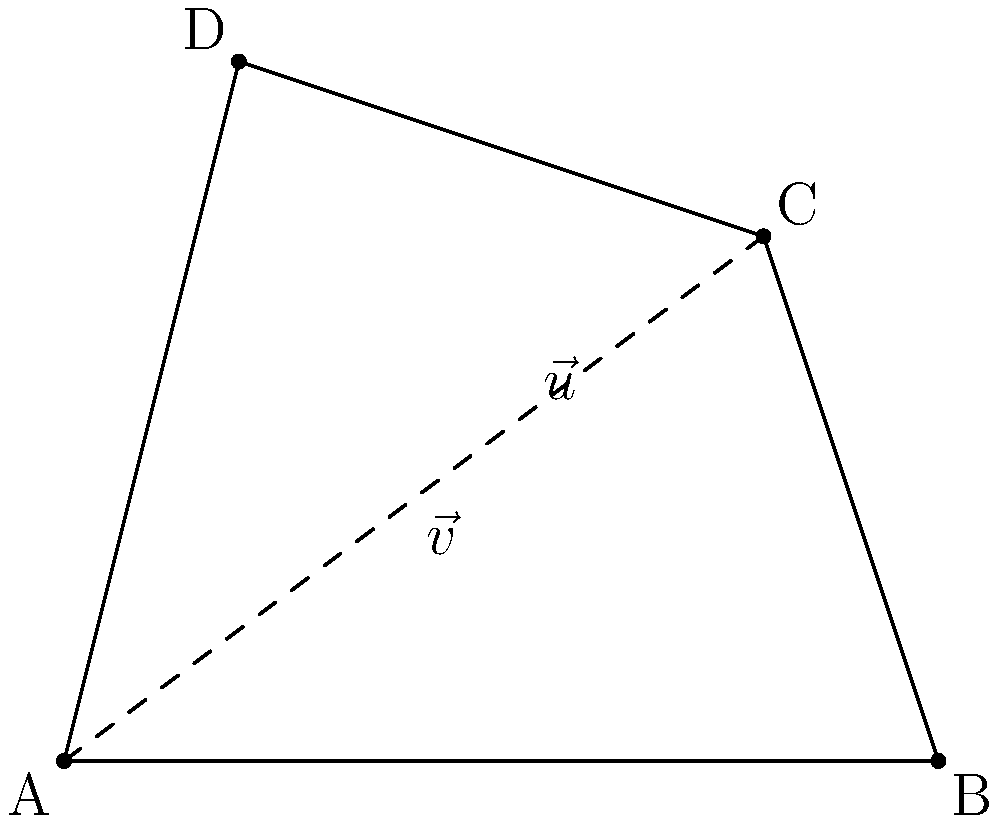You're planning to create a small vegetable garden in an irregularly shaped plot in your backyard. The plot can be approximated by a quadrilateral ABCD, where $\vec{v} = \overrightarrow{AC}$ and $\vec{u} = \overrightarrow{BD}$ are the diagonals. If $\vec{v} = 4\hat{i} + 3\hat{j}$ and $\vec{u} = -4\hat{i} + 4\hat{j}$, what is the area of the garden plot in square meters? To find the area of the quadrilateral using vector multiplication, we can follow these steps:

1) The area of a quadrilateral can be calculated using the formula:
   
   $$ \text{Area} = \frac{1}{2}|\vec{v} \times \vec{u}| $$

   Where $\vec{v}$ and $\vec{u}$ are the diagonal vectors and $\times$ denotes the cross product.

2) We are given:
   $\vec{v} = 4\hat{i} + 3\hat{j}$
   $\vec{u} = -4\hat{i} + 4\hat{j}$

3) To calculate the cross product in 2D, we can use the determinant method:

   $$ \vec{v} \times \vec{u} = \begin{vmatrix} 
   4 & 3 \\
   -4 & 4
   \end{vmatrix} = (4)(4) - (3)(-4) = 16 + 12 = 28 $$

4) The magnitude of this cross product is 28.

5) Now we can apply the area formula:

   $$ \text{Area} = \frac{1}{2}|28| = 14 $$

Therefore, the area of the garden plot is 14 square meters.
Answer: 14 square meters 